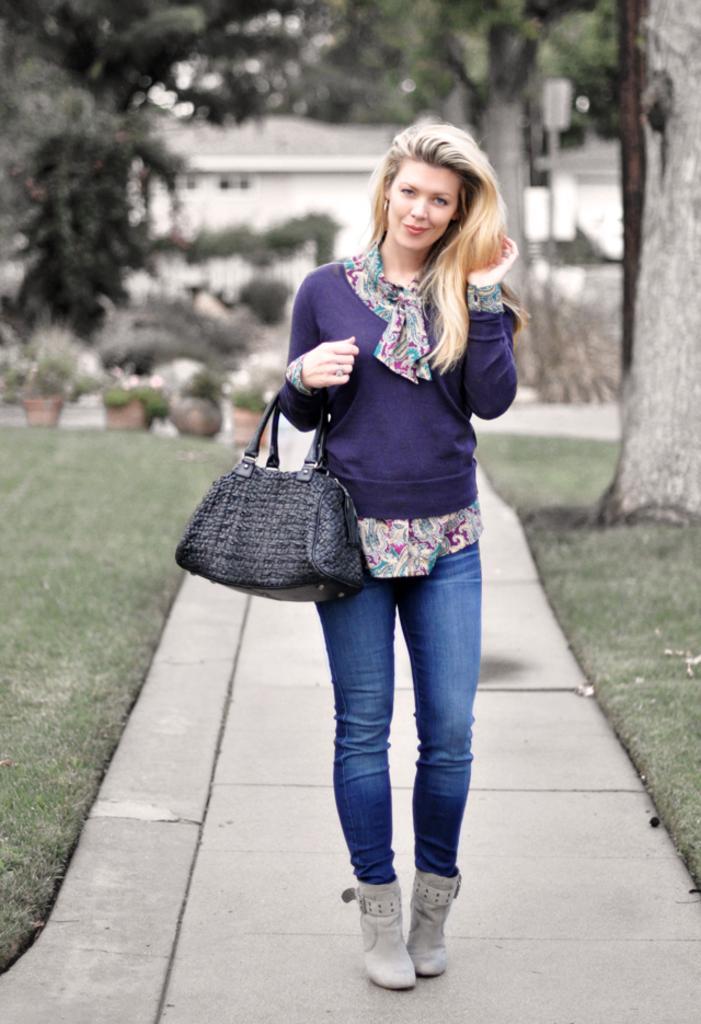In one or two sentences, can you explain what this image depicts? This image is taken in outdoors. In the left side of the image there is a grass and a pots with the small plants. In the right side of the image there is a tree and at the background there is a house with wall and window. In the middle of the image there is a pavement and a woman wearing a sweater and a jeans, boots, hand bag with long hair. 